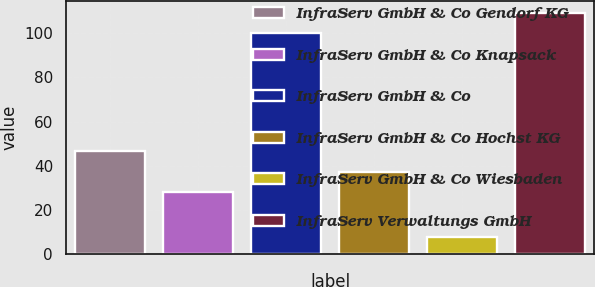Convert chart. <chart><loc_0><loc_0><loc_500><loc_500><bar_chart><fcel>InfraServ GmbH & Co Gendorf KG<fcel>InfraServ GmbH & Co Knapsack<fcel>InfraServ GmbH & Co<fcel>InfraServ GmbH & Co Hochst KG<fcel>InfraServ GmbH & Co Wiesbaden<fcel>InfraServ Verwaltungs GmbH<nl><fcel>46.62<fcel>28.2<fcel>100<fcel>37.41<fcel>7.9<fcel>109.21<nl></chart> 